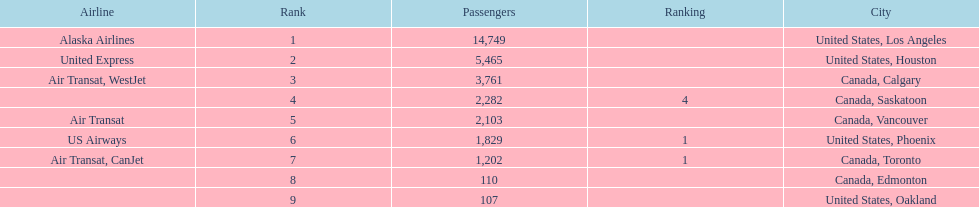Which canadian city had the most passengers traveling from manzanillo international airport in 2013? Calgary. 